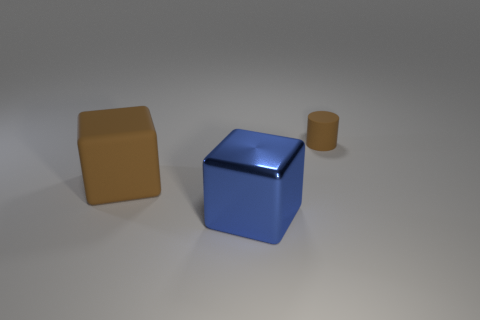How many big things are in front of the rubber object that is to the left of the large metal cube?
Offer a terse response. 1. There is a brown thing that is the same shape as the big blue shiny thing; what is its material?
Your answer should be compact. Rubber. What number of yellow things are large blocks or rubber blocks?
Your answer should be very brief. 0. Is there any other thing of the same color as the rubber cylinder?
Keep it short and to the point. Yes. There is a small object that is behind the brown rubber cube on the left side of the tiny brown cylinder; what is its color?
Offer a terse response. Brown. Is the number of large metallic cubes that are right of the small brown rubber cylinder less than the number of blue cubes behind the big rubber object?
Keep it short and to the point. No. There is a cylinder that is the same color as the matte cube; what material is it?
Provide a succinct answer. Rubber. How many objects are objects in front of the rubber cylinder or large blue objects?
Your answer should be compact. 2. Does the blue cube to the right of the brown block have the same size as the brown cube?
Your answer should be compact. Yes. Are there fewer metallic cubes to the left of the big blue object than tiny gray things?
Keep it short and to the point. No. 